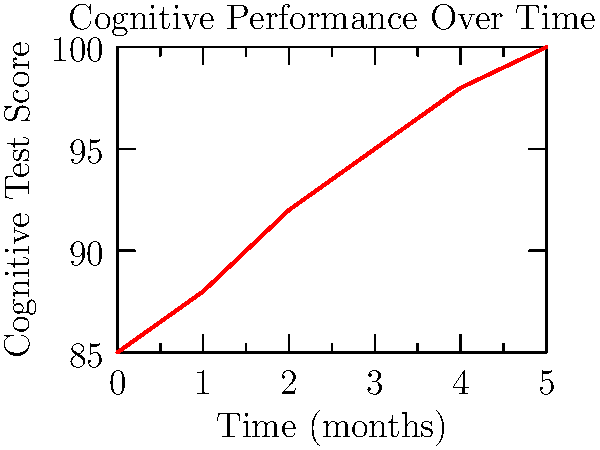Looking at the line graph, what is the approximate increase in cognitive test score between month 0 and month 5 of the study? To find the increase in cognitive test score, we need to:

1. Identify the starting point (month 0) score:
   The score at month 0 is approximately 85.

2. Identify the ending point (month 5) score:
   The score at month 5 is 100.

3. Calculate the difference:
   $100 - 85 = 15$

Therefore, the cognitive test score increased by approximately 15 points from month 0 to month 5.
Answer: 15 points 